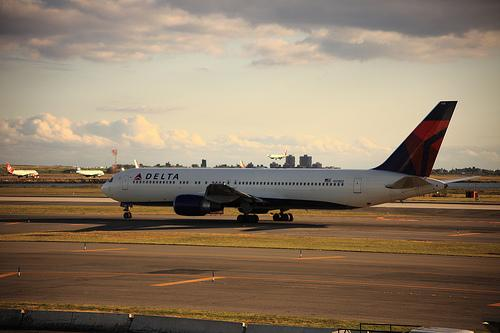Describe the state of the sky in the image. The sky in the image is blue with fluffy white clouds, some grey and dark clouds. List down the parts of the delta airplane that are visible in the image. Nose, name and logo, windows, front hatch, tail, wheels, wing, engine, and vertical stabilizer. Analyze the sentiment present in the image based on its elements. The image sentiment can be perceived as calm and routine, as airplanes are waiting and preparing for takeoff in an airport setting. In the context of the given image, what do you think the orange flag on the ground represents? The orange flag might represent a warning, indicator or guidance for ground personnel at the airport. What is the quality of the image with respect to its color and focus? The image quality seems fine with good color representation and clear focus on the objects. Describe the condition of the runway in the image. The runway is empty with yellow paint on the road and grass in the median. Count the number of airplanes present in the image and describe their placements. There are 1 delta airplane on the ground, 1 airplane on a runway, 3 airplanes in the distant runway, and 3 airplanes flying in the air. Can you see any clouds in the image? If yes, describe their colors and positions. Yes, there are white, grey, and dark clouds in the sky, spread through various positions. Evaluate the presence of any object interactions in the image. There isn't significant object interaction, mainly objects such as airplanes situated in the airport environment waiting for takeoff or landing. Look out for the control tower behind the delta airplane. It's quite tall and has antennas on top. No, it's not mentioned in the image. 